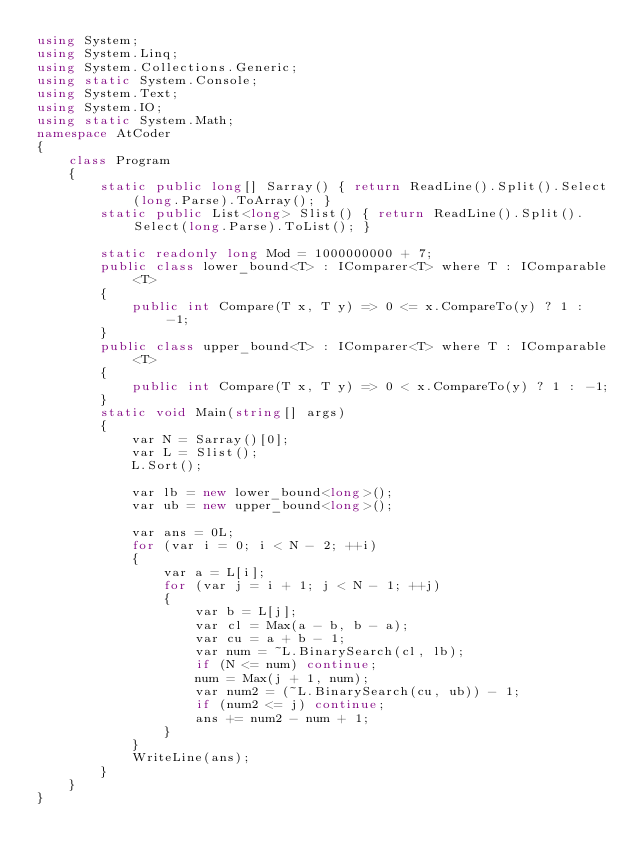Convert code to text. <code><loc_0><loc_0><loc_500><loc_500><_C#_>using System;
using System.Linq;
using System.Collections.Generic;
using static System.Console;
using System.Text;
using System.IO;
using static System.Math;
namespace AtCoder
{
    class Program
    {
        static public long[] Sarray() { return ReadLine().Split().Select(long.Parse).ToArray(); }
        static public List<long> Slist() { return ReadLine().Split().Select(long.Parse).ToList(); }

        static readonly long Mod = 1000000000 + 7;
        public class lower_bound<T> : IComparer<T> where T : IComparable<T>
        {
            public int Compare(T x, T y) => 0 <= x.CompareTo(y) ? 1 : -1;
        }
        public class upper_bound<T> : IComparer<T> where T : IComparable<T>
        {
            public int Compare(T x, T y) => 0 < x.CompareTo(y) ? 1 : -1;
        }
        static void Main(string[] args)
        {
            var N = Sarray()[0];
            var L = Slist();
            L.Sort();
            
            var lb = new lower_bound<long>();
            var ub = new upper_bound<long>();

            var ans = 0L;
            for (var i = 0; i < N - 2; ++i)
            {
                var a = L[i];
                for (var j = i + 1; j < N - 1; ++j) 
                {
                    var b = L[j];
                    var cl = Max(a - b, b - a);
                    var cu = a + b - 1;
                    var num = ~L.BinarySearch(cl, lb);
                    if (N <= num) continue;
                    num = Max(j + 1, num);
                    var num2 = (~L.BinarySearch(cu, ub)) - 1;
                    if (num2 <= j) continue;
                    ans += num2 - num + 1;
                }
            }
            WriteLine(ans);
        }
    }
}</code> 